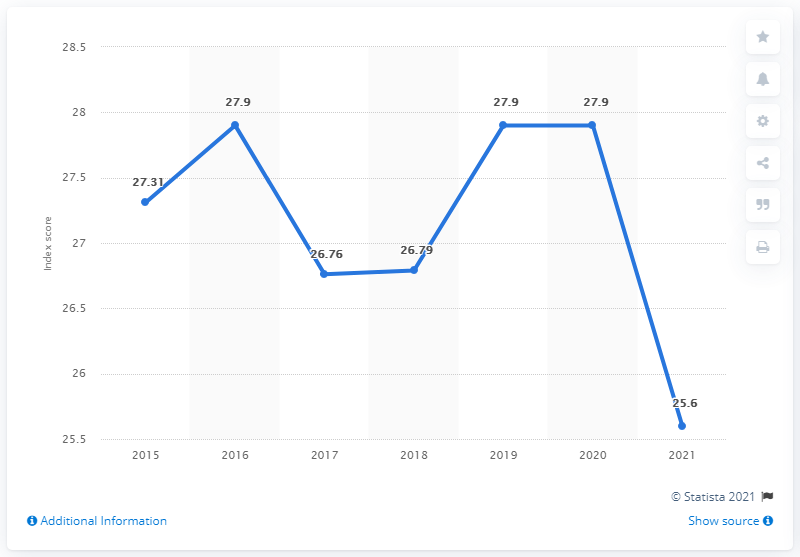Give some essential details in this illustration. In the previous year, the Dominican Republic's press freedom index was 27.9. 